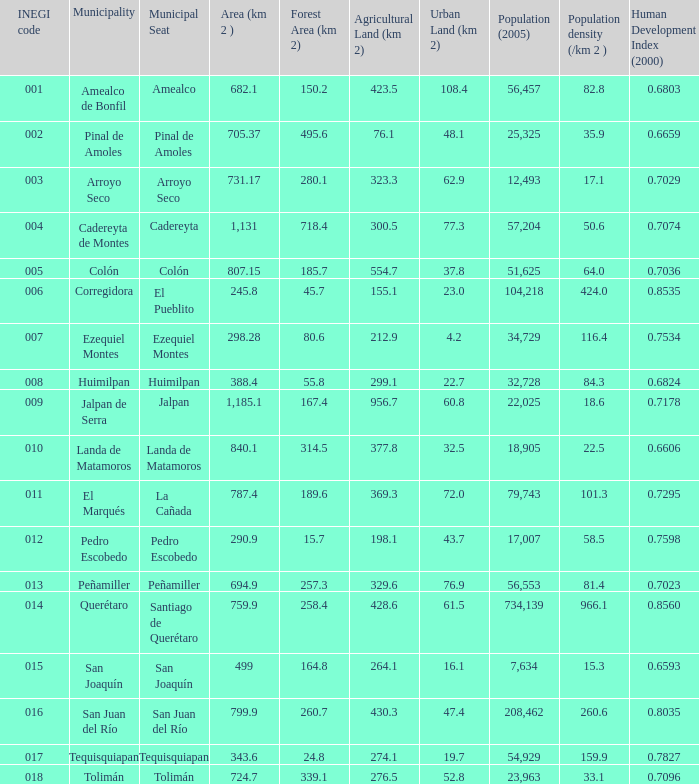Which Area (km 2 )has a Population (2005) of 57,204, and a Human Development Index (2000) smaller than 0.7074? 0.0. 